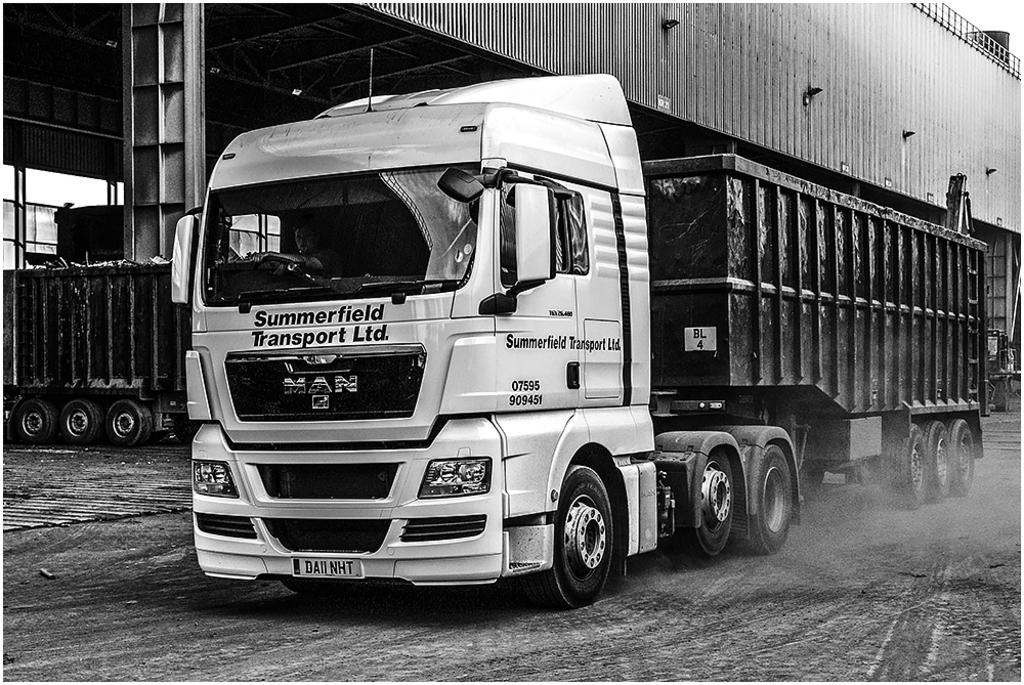Can you describe this image briefly? In this picture we can see a vehicle on the ground with a person in it and in the background we can see a vehicle, shelter, rods and some objects. 